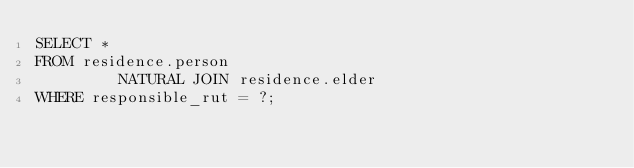Convert code to text. <code><loc_0><loc_0><loc_500><loc_500><_SQL_>SELECT *
FROM residence.person
         NATURAL JOIN residence.elder
WHERE responsible_rut = ?;</code> 